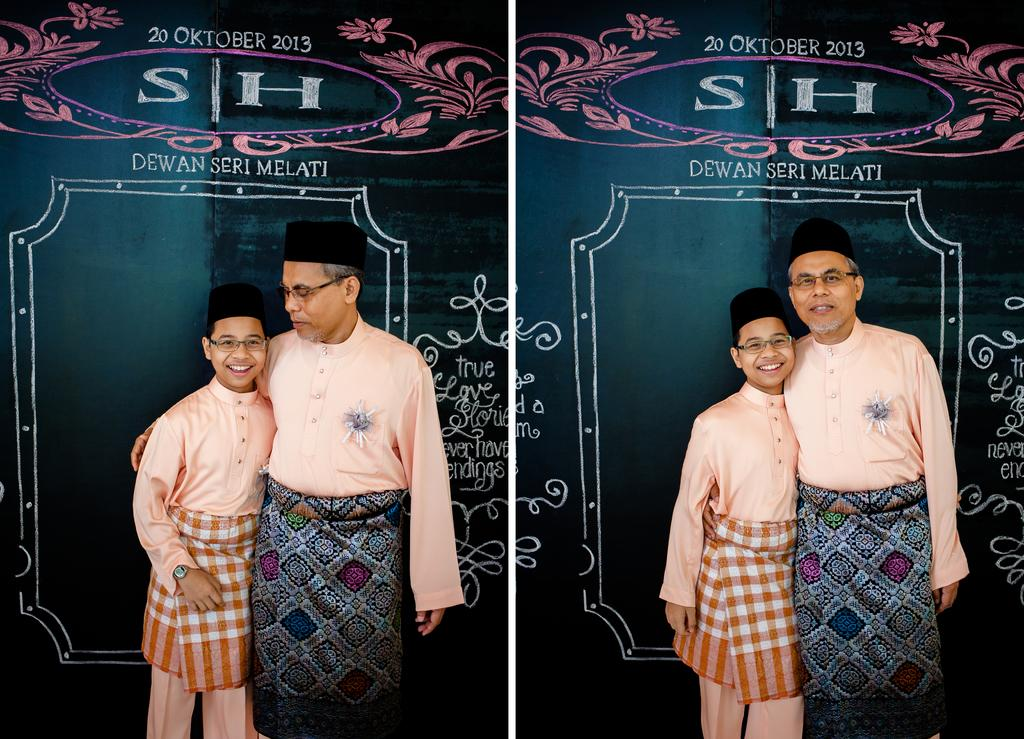What type of picture is the image? The image is a collage picture. What can be seen in the image besides the collage? There are persons standing in the image. Where are the persons standing? The persons are standing on the floor. What is visible in the background of the image? There is a board in the background of the image. What type of square apparel do the persons in the image have on their heads? There is no square apparel present on the persons' heads in the image. 